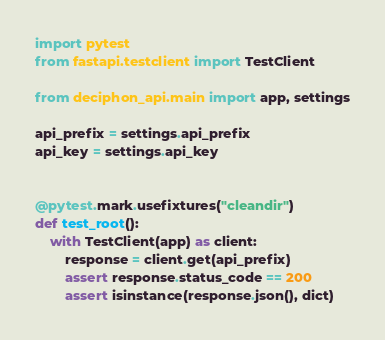Convert code to text. <code><loc_0><loc_0><loc_500><loc_500><_Python_>import pytest
from fastapi.testclient import TestClient

from deciphon_api.main import app, settings

api_prefix = settings.api_prefix
api_key = settings.api_key


@pytest.mark.usefixtures("cleandir")
def test_root():
    with TestClient(app) as client:
        response = client.get(api_prefix)
        assert response.status_code == 200
        assert isinstance(response.json(), dict)
</code> 